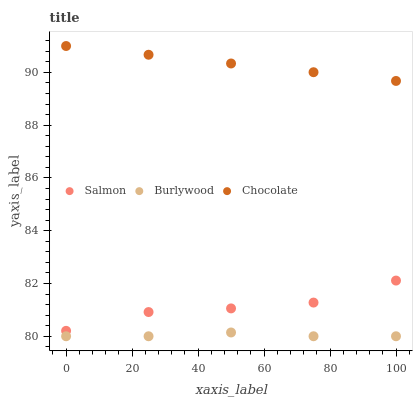Does Burlywood have the minimum area under the curve?
Answer yes or no. Yes. Does Chocolate have the maximum area under the curve?
Answer yes or no. Yes. Does Salmon have the minimum area under the curve?
Answer yes or no. No. Does Salmon have the maximum area under the curve?
Answer yes or no. No. Is Chocolate the smoothest?
Answer yes or no. Yes. Is Salmon the roughest?
Answer yes or no. Yes. Is Salmon the smoothest?
Answer yes or no. No. Is Chocolate the roughest?
Answer yes or no. No. Does Burlywood have the lowest value?
Answer yes or no. Yes. Does Salmon have the lowest value?
Answer yes or no. No. Does Chocolate have the highest value?
Answer yes or no. Yes. Does Salmon have the highest value?
Answer yes or no. No. Is Burlywood less than Salmon?
Answer yes or no. Yes. Is Salmon greater than Burlywood?
Answer yes or no. Yes. Does Burlywood intersect Salmon?
Answer yes or no. No. 